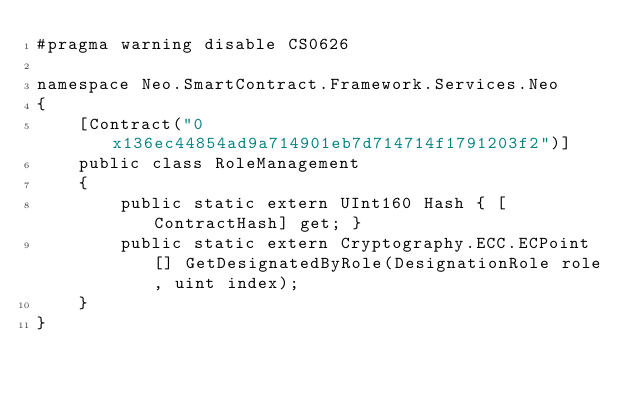<code> <loc_0><loc_0><loc_500><loc_500><_C#_>#pragma warning disable CS0626

namespace Neo.SmartContract.Framework.Services.Neo
{
    [Contract("0x136ec44854ad9a714901eb7d714714f1791203f2")]
    public class RoleManagement
    {
        public static extern UInt160 Hash { [ContractHash] get; }
        public static extern Cryptography.ECC.ECPoint[] GetDesignatedByRole(DesignationRole role, uint index);
    }
}
</code> 